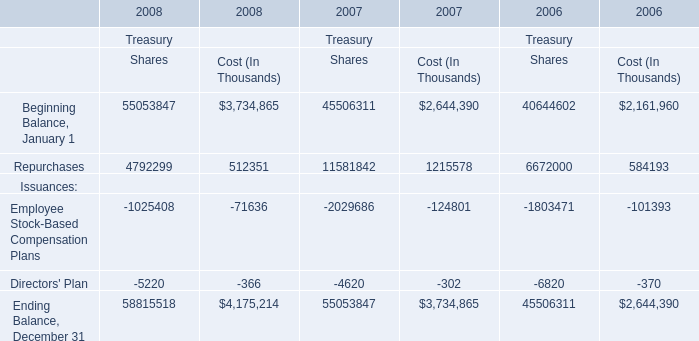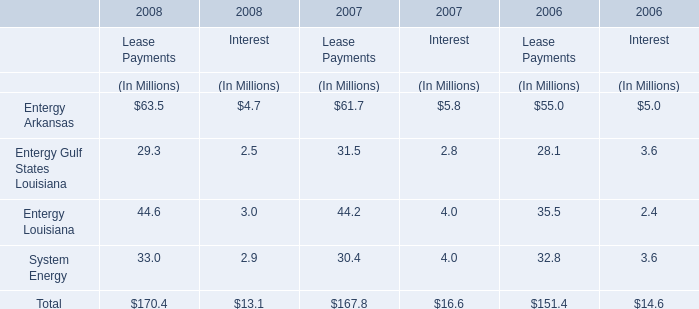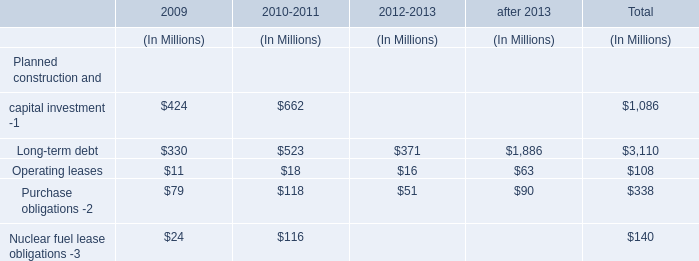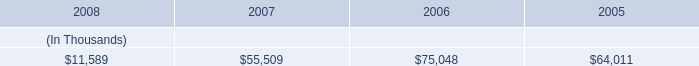what is the annual interest expense related to series first mortgage bonds due may 2018 , in millions? 
Computations: (375 * 6.00%)
Answer: 22.5. 